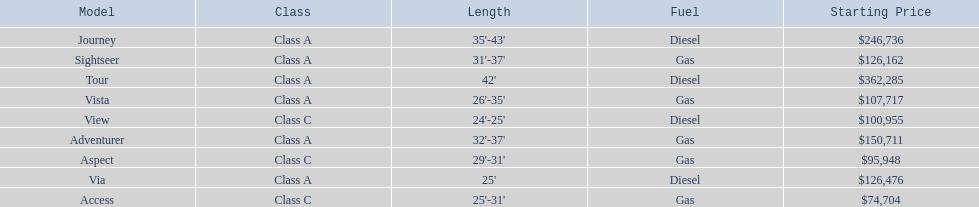What are the prices? $362,285, $246,736, $150,711, $126,476, $126,162, $107,717, $100,955, $95,948, $74,704. What is the top price? $362,285. What model has this price? Tour. 